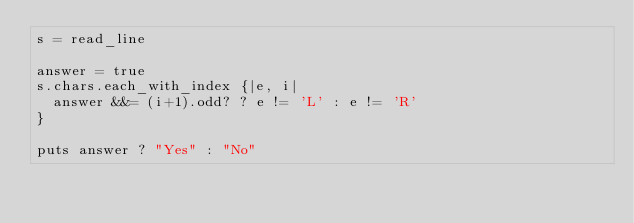<code> <loc_0><loc_0><loc_500><loc_500><_Crystal_>s = read_line

answer = true
s.chars.each_with_index {|e, i|
  answer &&= (i+1).odd? ? e != 'L' : e != 'R'
}

puts answer ? "Yes" : "No"
</code> 